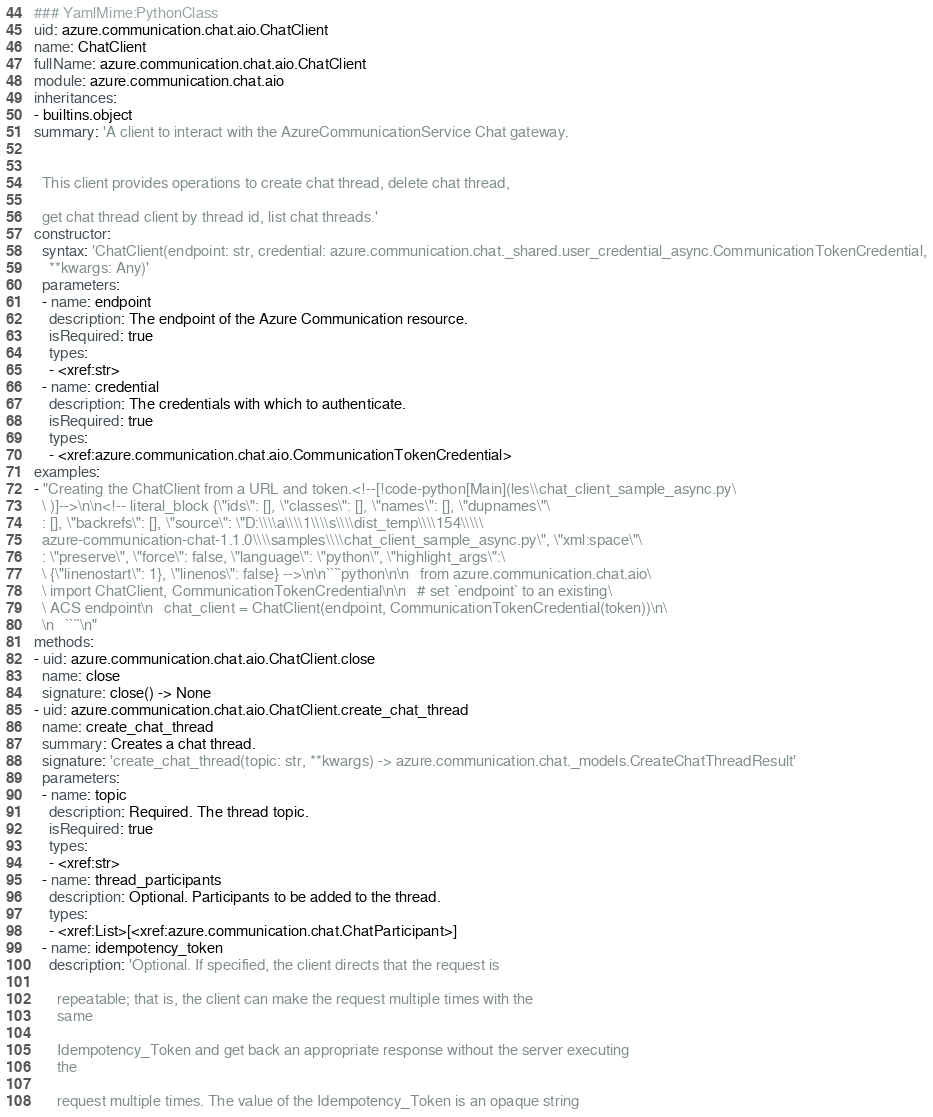Convert code to text. <code><loc_0><loc_0><loc_500><loc_500><_YAML_>### YamlMime:PythonClass
uid: azure.communication.chat.aio.ChatClient
name: ChatClient
fullName: azure.communication.chat.aio.ChatClient
module: azure.communication.chat.aio
inheritances:
- builtins.object
summary: 'A client to interact with the AzureCommunicationService Chat gateway.


  This client provides operations to create chat thread, delete chat thread,

  get chat thread client by thread id, list chat threads.'
constructor:
  syntax: 'ChatClient(endpoint: str, credential: azure.communication.chat._shared.user_credential_async.CommunicationTokenCredential,
    **kwargs: Any)'
  parameters:
  - name: endpoint
    description: The endpoint of the Azure Communication resource.
    isRequired: true
    types:
    - <xref:str>
  - name: credential
    description: The credentials with which to authenticate.
    isRequired: true
    types:
    - <xref:azure.communication.chat.aio.CommunicationTokenCredential>
examples:
- "Creating the ChatClient from a URL and token.<!--[!code-python[Main](les\\chat_client_sample_async.py\
  \ )]-->\n\n<!-- literal_block {\"ids\": [], \"classes\": [], \"names\": [], \"dupnames\"\
  : [], \"backrefs\": [], \"source\": \"D:\\\\a\\\\1\\\\s\\\\dist_temp\\\\154\\\\\
  azure-communication-chat-1.1.0\\\\samples\\\\chat_client_sample_async.py\", \"xml:space\"\
  : \"preserve\", \"force\": false, \"language\": \"python\", \"highlight_args\":\
  \ {\"linenostart\": 1}, \"linenos\": false} -->\n\n````python\n\n   from azure.communication.chat.aio\
  \ import ChatClient, CommunicationTokenCredential\n\n   # set `endpoint` to an existing\
  \ ACS endpoint\n   chat_client = ChatClient(endpoint, CommunicationTokenCredential(token))\n\
  \n   ````\n"
methods:
- uid: azure.communication.chat.aio.ChatClient.close
  name: close
  signature: close() -> None
- uid: azure.communication.chat.aio.ChatClient.create_chat_thread
  name: create_chat_thread
  summary: Creates a chat thread.
  signature: 'create_chat_thread(topic: str, **kwargs) -> azure.communication.chat._models.CreateChatThreadResult'
  parameters:
  - name: topic
    description: Required. The thread topic.
    isRequired: true
    types:
    - <xref:str>
  - name: thread_participants
    description: Optional. Participants to be added to the thread.
    types:
    - <xref:List>[<xref:azure.communication.chat.ChatParticipant>]
  - name: idempotency_token
    description: 'Optional. If specified, the client directs that the request is

      repeatable; that is, the client can make the request multiple times with the
      same

      Idempotency_Token and get back an appropriate response without the server executing
      the

      request multiple times. The value of the Idempotency_Token is an opaque string
</code> 